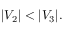<formula> <loc_0><loc_0><loc_500><loc_500>| V _ { 2 } | < | V _ { 3 } | .</formula> 